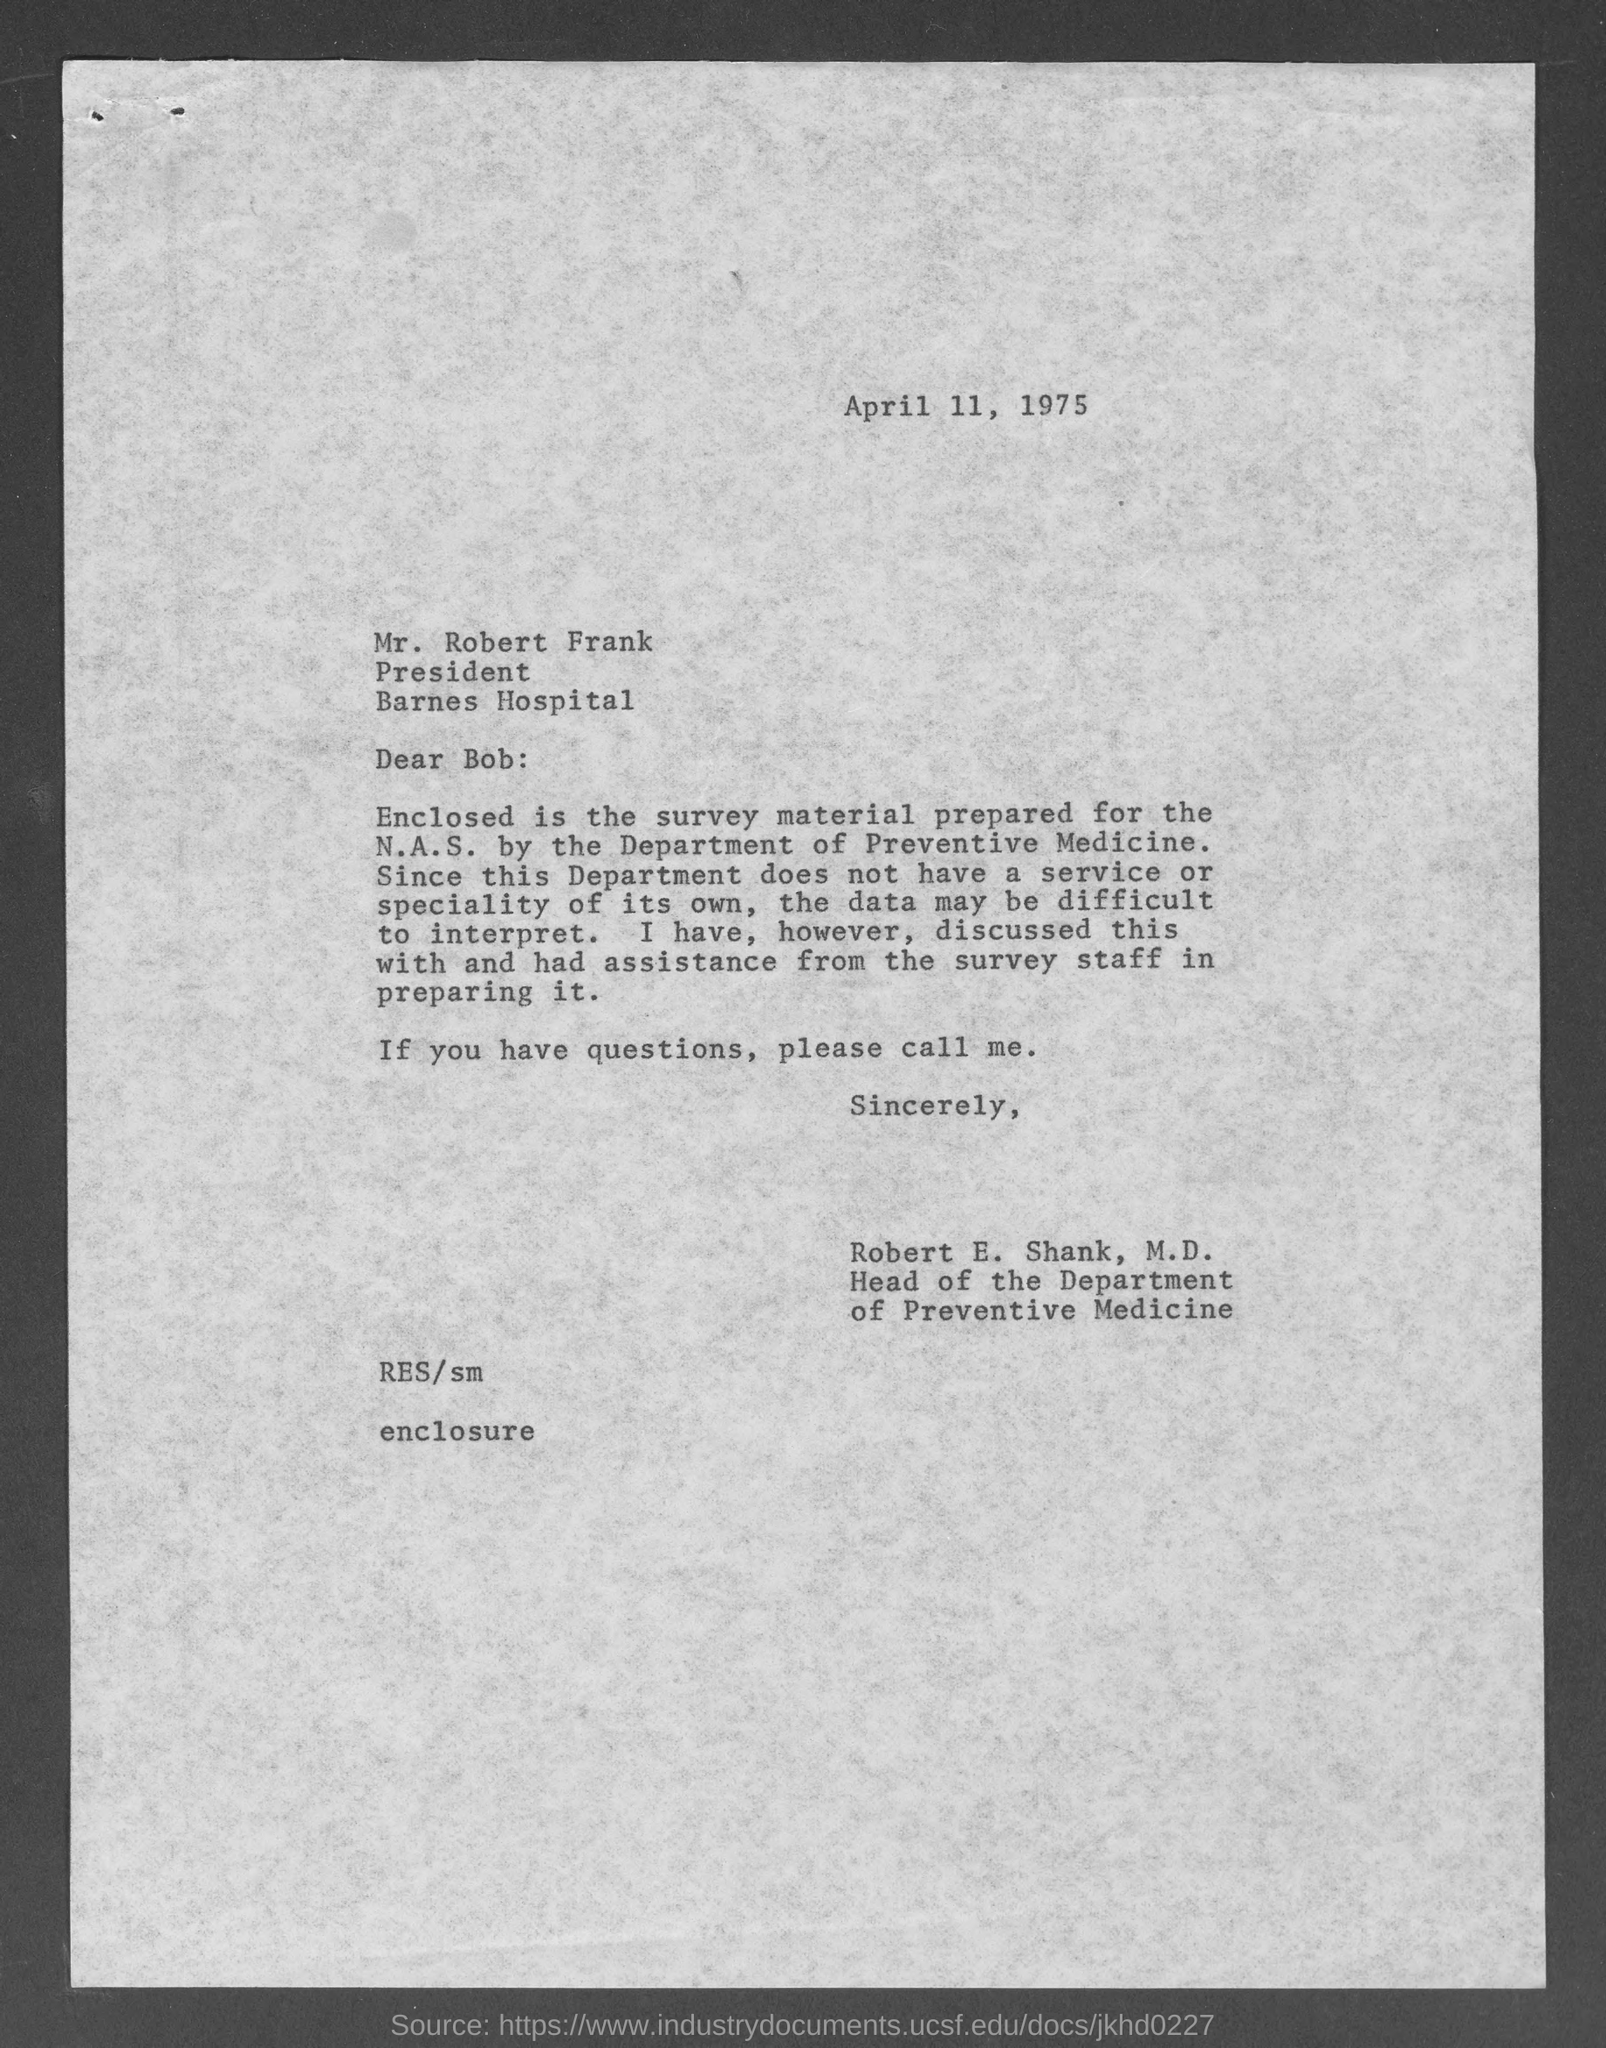Outline some significant characteristics in this image. Robert E. Shank, M.D. holds the position of head of the department of preventive medicine. The letter is dated April 11, 1975. The writer of this letter is Robert E. Shank, M.D. The letter is addressed to Mr. Robert Frank. Mr. Robert Frank holds the position of President. 